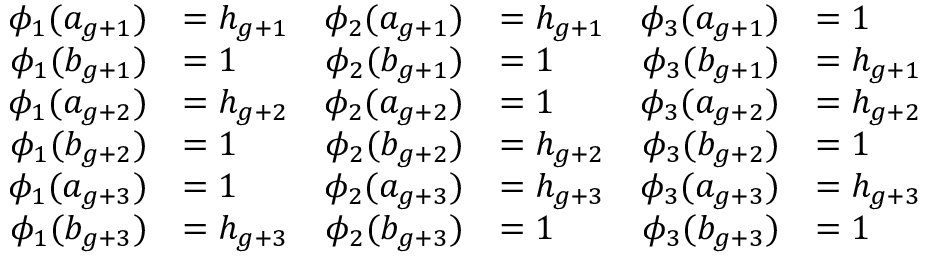<formula> <loc_0><loc_0><loc_500><loc_500>\begin{array} { r l r l r l } { \phi _ { 1 } ( a _ { g + 1 } ) } & { = h _ { g + 1 } } & { \phi _ { 2 } ( a _ { g + 1 } ) } & { = h _ { g + 1 } } & { \phi _ { 3 } ( a _ { g + 1 } ) } & { = 1 } \\ { \phi _ { 1 } ( b _ { g + 1 } ) } & { = 1 } & { \phi _ { 2 } ( b _ { g + 1 } ) } & { = 1 } & { \phi _ { 3 } ( b _ { g + 1 } ) } & { = h _ { g + 1 } } \\ { \phi _ { 1 } ( a _ { g + 2 } ) } & { = h _ { g + 2 } } & { \phi _ { 2 } ( a _ { g + 2 } ) } & { = 1 } & { \phi _ { 3 } ( a _ { g + 2 } ) } & { = h _ { g + 2 } } \\ { \phi _ { 1 } ( b _ { g + 2 } ) } & { = 1 } & { \phi _ { 2 } ( b _ { g + 2 } ) } & { = h _ { g + 2 } } & { \phi _ { 3 } ( b _ { g + 2 } ) } & { = 1 } \\ { \phi _ { 1 } ( a _ { g + 3 } ) } & { = 1 } & { \phi _ { 2 } ( a _ { g + 3 } ) } & { = h _ { g + 3 } } & { \phi _ { 3 } ( a _ { g + 3 } ) } & { = h _ { g + 3 } } \\ { \phi _ { 1 } ( b _ { g + 3 } ) } & { = h _ { g + 3 } } & { \phi _ { 2 } ( b _ { g + 3 } ) } & { = 1 } & { \phi _ { 3 } ( b _ { g + 3 } ) } & { = 1 } \end{array}</formula> 